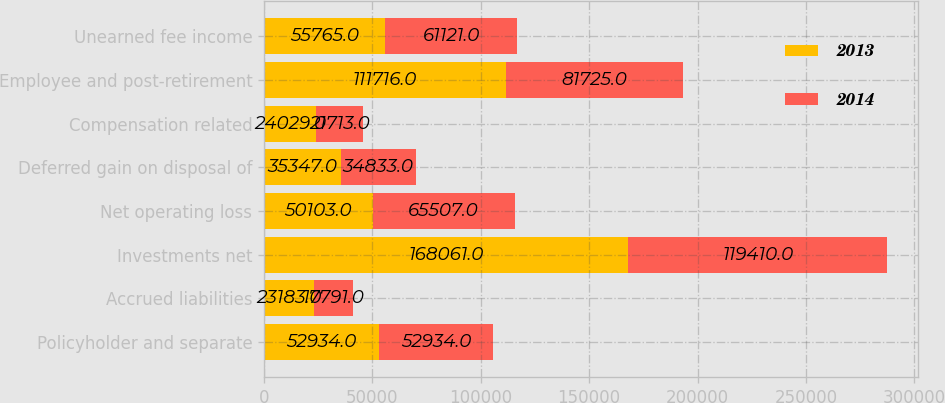Convert chart. <chart><loc_0><loc_0><loc_500><loc_500><stacked_bar_chart><ecel><fcel>Policyholder and separate<fcel>Accrued liabilities<fcel>Investments net<fcel>Net operating loss<fcel>Deferred gain on disposal of<fcel>Compensation related<fcel>Employee and post-retirement<fcel>Unearned fee income<nl><fcel>2013<fcel>52934<fcel>23183<fcel>168061<fcel>50103<fcel>35347<fcel>24029<fcel>111716<fcel>55765<nl><fcel>2014<fcel>52934<fcel>17791<fcel>119410<fcel>65507<fcel>34833<fcel>21713<fcel>81725<fcel>61121<nl></chart> 